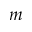Convert formula to latex. <formula><loc_0><loc_0><loc_500><loc_500>m</formula> 